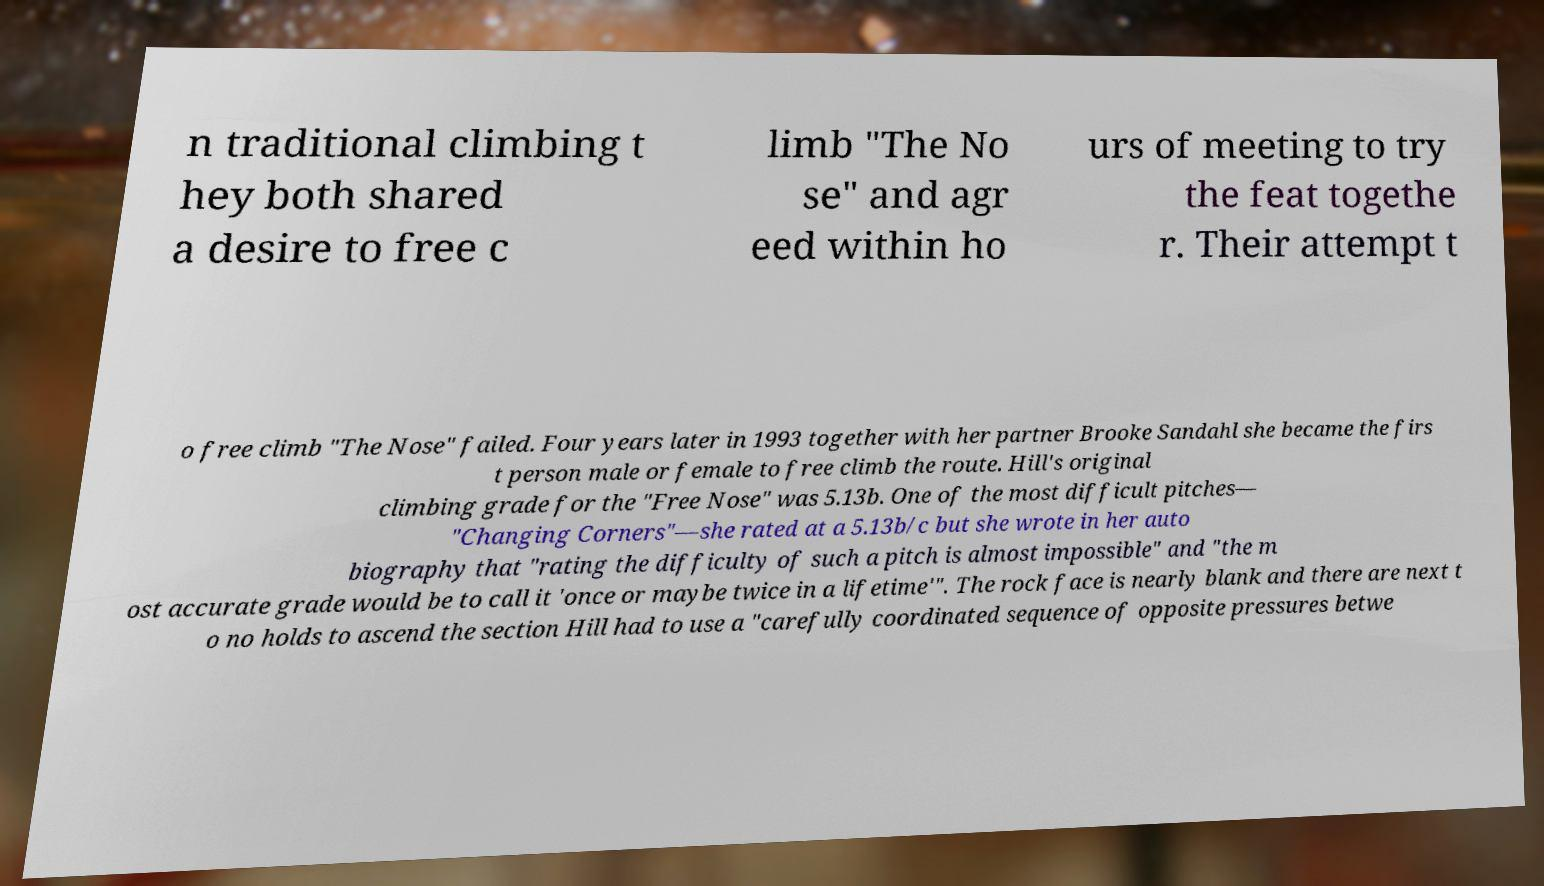There's text embedded in this image that I need extracted. Can you transcribe it verbatim? n traditional climbing t hey both shared a desire to free c limb "The No se" and agr eed within ho urs of meeting to try the feat togethe r. Their attempt t o free climb "The Nose" failed. Four years later in 1993 together with her partner Brooke Sandahl she became the firs t person male or female to free climb the route. Hill's original climbing grade for the "Free Nose" was 5.13b. One of the most difficult pitches— "Changing Corners"—she rated at a 5.13b/c but she wrote in her auto biography that "rating the difficulty of such a pitch is almost impossible" and "the m ost accurate grade would be to call it 'once or maybe twice in a lifetime'". The rock face is nearly blank and there are next t o no holds to ascend the section Hill had to use a "carefully coordinated sequence of opposite pressures betwe 